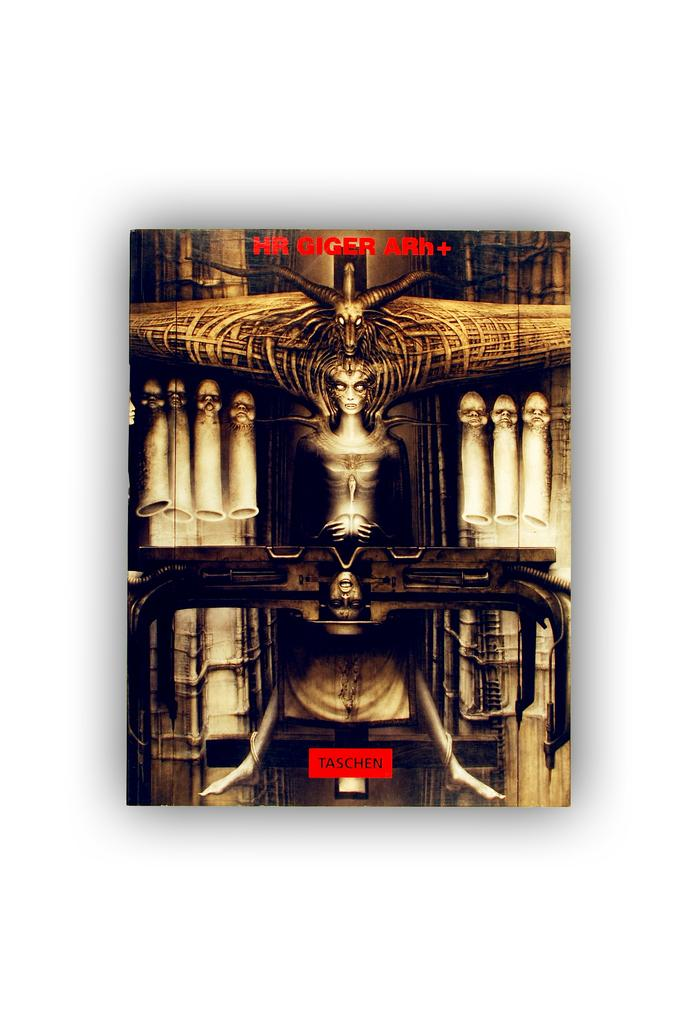<image>
Give a short and clear explanation of the subsequent image. An unusual spooky poster with the word Taschen at the bottom. 